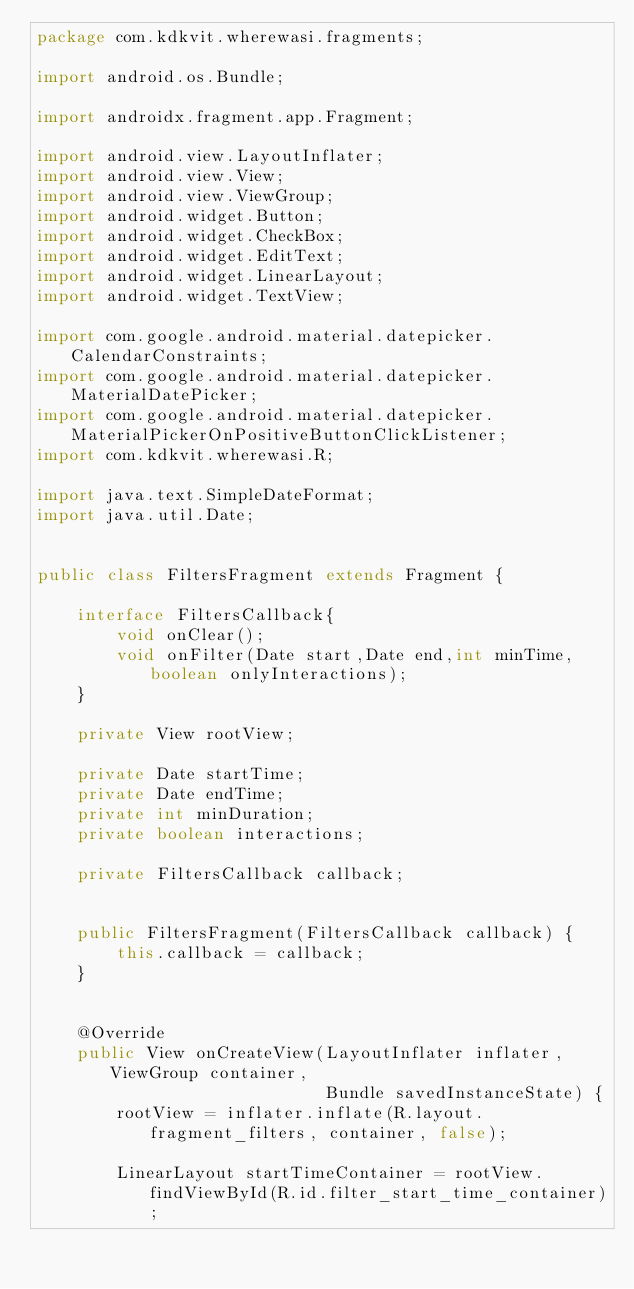<code> <loc_0><loc_0><loc_500><loc_500><_Java_>package com.kdkvit.wherewasi.fragments;

import android.os.Bundle;

import androidx.fragment.app.Fragment;

import android.view.LayoutInflater;
import android.view.View;
import android.view.ViewGroup;
import android.widget.Button;
import android.widget.CheckBox;
import android.widget.EditText;
import android.widget.LinearLayout;
import android.widget.TextView;

import com.google.android.material.datepicker.CalendarConstraints;
import com.google.android.material.datepicker.MaterialDatePicker;
import com.google.android.material.datepicker.MaterialPickerOnPositiveButtonClickListener;
import com.kdkvit.wherewasi.R;

import java.text.SimpleDateFormat;
import java.util.Date;


public class FiltersFragment extends Fragment {

    interface FiltersCallback{
        void onClear();
        void onFilter(Date start,Date end,int minTime,boolean onlyInteractions);
    }

    private View rootView;

    private Date startTime;
    private Date endTime;
    private int minDuration;
    private boolean interactions;

    private FiltersCallback callback;


    public FiltersFragment(FiltersCallback callback) {
        this.callback = callback;
    }


    @Override
    public View onCreateView(LayoutInflater inflater, ViewGroup container,
                             Bundle savedInstanceState) {
        rootView = inflater.inflate(R.layout.fragment_filters, container, false);

        LinearLayout startTimeContainer = rootView.findViewById(R.id.filter_start_time_container);</code> 